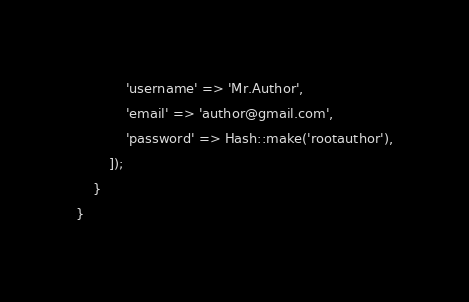Convert code to text. <code><loc_0><loc_0><loc_500><loc_500><_PHP_>            'username' => 'Mr.Author',
            'email' => 'author@gmail.com',
            'password' => Hash::make('rootauthor'),
        ]);
    }
}
</code> 